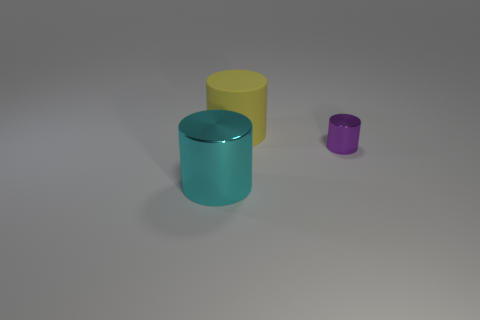Is there anything else that has the same material as the large yellow object?
Give a very brief answer. No. There is a cyan metallic cylinder in front of the rubber object; what is its size?
Your answer should be very brief. Large. What number of cyan metallic objects have the same size as the yellow cylinder?
Give a very brief answer. 1. There is a thing that is both behind the cyan object and in front of the big matte cylinder; what material is it?
Offer a terse response. Metal. There is a object that is the same size as the yellow cylinder; what is its material?
Offer a very short reply. Metal. There is a shiny thing that is right of the large object in front of the big thing behind the small purple cylinder; how big is it?
Offer a very short reply. Small. There is a cylinder that is made of the same material as the small purple thing; what size is it?
Provide a short and direct response. Large. There is a yellow matte thing; is it the same size as the shiny cylinder on the right side of the big cyan metallic cylinder?
Ensure brevity in your answer.  No. There is a object behind the purple object; what shape is it?
Offer a terse response. Cylinder. There is a large cylinder in front of the thing to the right of the matte object; are there any small purple cylinders to the left of it?
Your answer should be compact. No. 